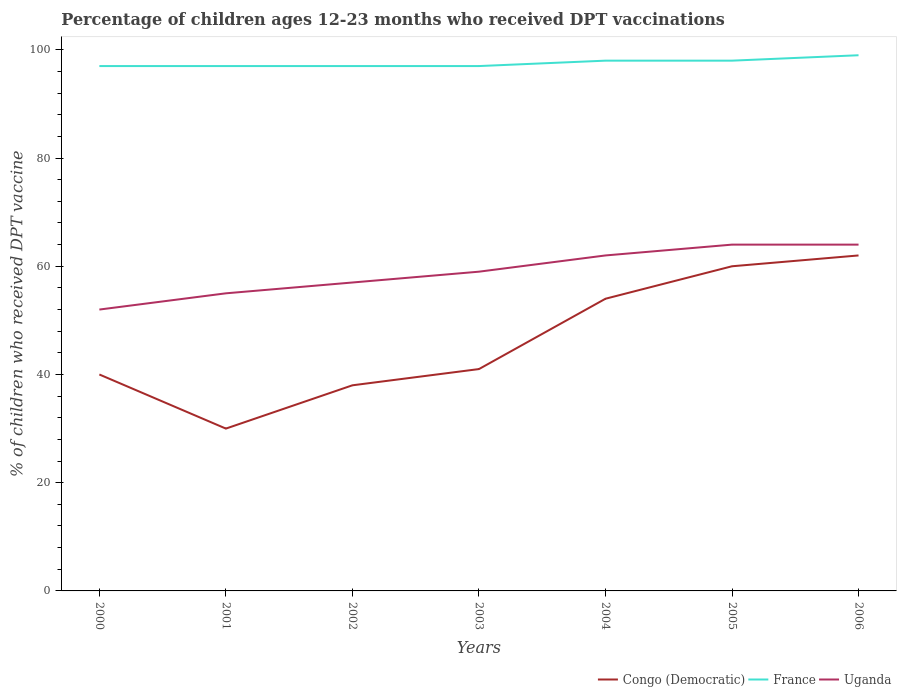How many different coloured lines are there?
Your answer should be compact. 3. Does the line corresponding to Uganda intersect with the line corresponding to France?
Your response must be concise. No. What is the difference between the highest and the second highest percentage of children who received DPT vaccination in France?
Provide a succinct answer. 2. What is the difference between the highest and the lowest percentage of children who received DPT vaccination in Uganda?
Provide a short and direct response. 3. Is the percentage of children who received DPT vaccination in France strictly greater than the percentage of children who received DPT vaccination in Uganda over the years?
Your response must be concise. No. How many lines are there?
Keep it short and to the point. 3. How many legend labels are there?
Make the answer very short. 3. How are the legend labels stacked?
Your response must be concise. Horizontal. What is the title of the graph?
Your answer should be compact. Percentage of children ages 12-23 months who received DPT vaccinations. What is the label or title of the Y-axis?
Offer a terse response. % of children who received DPT vaccine. What is the % of children who received DPT vaccine in Congo (Democratic) in 2000?
Your answer should be very brief. 40. What is the % of children who received DPT vaccine in France in 2000?
Your answer should be very brief. 97. What is the % of children who received DPT vaccine of France in 2001?
Provide a short and direct response. 97. What is the % of children who received DPT vaccine of Uganda in 2001?
Keep it short and to the point. 55. What is the % of children who received DPT vaccine in Congo (Democratic) in 2002?
Keep it short and to the point. 38. What is the % of children who received DPT vaccine of France in 2002?
Give a very brief answer. 97. What is the % of children who received DPT vaccine in Uganda in 2002?
Provide a short and direct response. 57. What is the % of children who received DPT vaccine in Congo (Democratic) in 2003?
Your response must be concise. 41. What is the % of children who received DPT vaccine of France in 2003?
Your response must be concise. 97. What is the % of children who received DPT vaccine in Uganda in 2004?
Provide a short and direct response. 62. What is the % of children who received DPT vaccine of Congo (Democratic) in 2006?
Ensure brevity in your answer.  62. What is the % of children who received DPT vaccine in France in 2006?
Ensure brevity in your answer.  99. What is the % of children who received DPT vaccine in Uganda in 2006?
Provide a short and direct response. 64. Across all years, what is the minimum % of children who received DPT vaccine in Congo (Democratic)?
Give a very brief answer. 30. Across all years, what is the minimum % of children who received DPT vaccine in France?
Provide a short and direct response. 97. What is the total % of children who received DPT vaccine of Congo (Democratic) in the graph?
Give a very brief answer. 325. What is the total % of children who received DPT vaccine of France in the graph?
Your response must be concise. 683. What is the total % of children who received DPT vaccine of Uganda in the graph?
Provide a short and direct response. 413. What is the difference between the % of children who received DPT vaccine in Congo (Democratic) in 2000 and that in 2002?
Give a very brief answer. 2. What is the difference between the % of children who received DPT vaccine of France in 2000 and that in 2002?
Give a very brief answer. 0. What is the difference between the % of children who received DPT vaccine in Uganda in 2000 and that in 2002?
Your answer should be very brief. -5. What is the difference between the % of children who received DPT vaccine of Congo (Democratic) in 2000 and that in 2003?
Ensure brevity in your answer.  -1. What is the difference between the % of children who received DPT vaccine in Uganda in 2000 and that in 2003?
Your answer should be very brief. -7. What is the difference between the % of children who received DPT vaccine of France in 2000 and that in 2004?
Your response must be concise. -1. What is the difference between the % of children who received DPT vaccine in Uganda in 2000 and that in 2004?
Make the answer very short. -10. What is the difference between the % of children who received DPT vaccine of Congo (Democratic) in 2000 and that in 2005?
Give a very brief answer. -20. What is the difference between the % of children who received DPT vaccine in France in 2000 and that in 2005?
Provide a short and direct response. -1. What is the difference between the % of children who received DPT vaccine in Uganda in 2000 and that in 2005?
Your answer should be compact. -12. What is the difference between the % of children who received DPT vaccine in France in 2000 and that in 2006?
Give a very brief answer. -2. What is the difference between the % of children who received DPT vaccine in Uganda in 2000 and that in 2006?
Give a very brief answer. -12. What is the difference between the % of children who received DPT vaccine of Congo (Democratic) in 2001 and that in 2002?
Make the answer very short. -8. What is the difference between the % of children who received DPT vaccine of France in 2001 and that in 2002?
Give a very brief answer. 0. What is the difference between the % of children who received DPT vaccine in Uganda in 2001 and that in 2002?
Make the answer very short. -2. What is the difference between the % of children who received DPT vaccine of Congo (Democratic) in 2001 and that in 2004?
Keep it short and to the point. -24. What is the difference between the % of children who received DPT vaccine of Uganda in 2001 and that in 2004?
Keep it short and to the point. -7. What is the difference between the % of children who received DPT vaccine of Congo (Democratic) in 2001 and that in 2005?
Give a very brief answer. -30. What is the difference between the % of children who received DPT vaccine of Uganda in 2001 and that in 2005?
Keep it short and to the point. -9. What is the difference between the % of children who received DPT vaccine in Congo (Democratic) in 2001 and that in 2006?
Provide a succinct answer. -32. What is the difference between the % of children who received DPT vaccine of Uganda in 2001 and that in 2006?
Ensure brevity in your answer.  -9. What is the difference between the % of children who received DPT vaccine in Congo (Democratic) in 2002 and that in 2003?
Provide a short and direct response. -3. What is the difference between the % of children who received DPT vaccine in Congo (Democratic) in 2002 and that in 2005?
Give a very brief answer. -22. What is the difference between the % of children who received DPT vaccine of France in 2002 and that in 2006?
Ensure brevity in your answer.  -2. What is the difference between the % of children who received DPT vaccine in Uganda in 2002 and that in 2006?
Keep it short and to the point. -7. What is the difference between the % of children who received DPT vaccine of Congo (Democratic) in 2003 and that in 2004?
Provide a succinct answer. -13. What is the difference between the % of children who received DPT vaccine of Uganda in 2003 and that in 2004?
Your answer should be compact. -3. What is the difference between the % of children who received DPT vaccine in Uganda in 2003 and that in 2005?
Your response must be concise. -5. What is the difference between the % of children who received DPT vaccine of Uganda in 2003 and that in 2006?
Ensure brevity in your answer.  -5. What is the difference between the % of children who received DPT vaccine in Congo (Democratic) in 2004 and that in 2005?
Give a very brief answer. -6. What is the difference between the % of children who received DPT vaccine of Congo (Democratic) in 2004 and that in 2006?
Your answer should be very brief. -8. What is the difference between the % of children who received DPT vaccine in France in 2004 and that in 2006?
Make the answer very short. -1. What is the difference between the % of children who received DPT vaccine of Uganda in 2004 and that in 2006?
Your response must be concise. -2. What is the difference between the % of children who received DPT vaccine in Congo (Democratic) in 2005 and that in 2006?
Give a very brief answer. -2. What is the difference between the % of children who received DPT vaccine of Uganda in 2005 and that in 2006?
Your answer should be very brief. 0. What is the difference between the % of children who received DPT vaccine in Congo (Democratic) in 2000 and the % of children who received DPT vaccine in France in 2001?
Give a very brief answer. -57. What is the difference between the % of children who received DPT vaccine of Congo (Democratic) in 2000 and the % of children who received DPT vaccine of Uganda in 2001?
Give a very brief answer. -15. What is the difference between the % of children who received DPT vaccine of France in 2000 and the % of children who received DPT vaccine of Uganda in 2001?
Provide a succinct answer. 42. What is the difference between the % of children who received DPT vaccine of Congo (Democratic) in 2000 and the % of children who received DPT vaccine of France in 2002?
Make the answer very short. -57. What is the difference between the % of children who received DPT vaccine in France in 2000 and the % of children who received DPT vaccine in Uganda in 2002?
Your response must be concise. 40. What is the difference between the % of children who received DPT vaccine of Congo (Democratic) in 2000 and the % of children who received DPT vaccine of France in 2003?
Offer a terse response. -57. What is the difference between the % of children who received DPT vaccine of Congo (Democratic) in 2000 and the % of children who received DPT vaccine of Uganda in 2003?
Provide a short and direct response. -19. What is the difference between the % of children who received DPT vaccine of France in 2000 and the % of children who received DPT vaccine of Uganda in 2003?
Provide a succinct answer. 38. What is the difference between the % of children who received DPT vaccine in Congo (Democratic) in 2000 and the % of children who received DPT vaccine in France in 2004?
Make the answer very short. -58. What is the difference between the % of children who received DPT vaccine of Congo (Democratic) in 2000 and the % of children who received DPT vaccine of France in 2005?
Keep it short and to the point. -58. What is the difference between the % of children who received DPT vaccine in France in 2000 and the % of children who received DPT vaccine in Uganda in 2005?
Your answer should be compact. 33. What is the difference between the % of children who received DPT vaccine in Congo (Democratic) in 2000 and the % of children who received DPT vaccine in France in 2006?
Your answer should be compact. -59. What is the difference between the % of children who received DPT vaccine in Congo (Democratic) in 2001 and the % of children who received DPT vaccine in France in 2002?
Your answer should be compact. -67. What is the difference between the % of children who received DPT vaccine of Congo (Democratic) in 2001 and the % of children who received DPT vaccine of France in 2003?
Your answer should be very brief. -67. What is the difference between the % of children who received DPT vaccine of Congo (Democratic) in 2001 and the % of children who received DPT vaccine of France in 2004?
Give a very brief answer. -68. What is the difference between the % of children who received DPT vaccine of Congo (Democratic) in 2001 and the % of children who received DPT vaccine of Uganda in 2004?
Provide a short and direct response. -32. What is the difference between the % of children who received DPT vaccine in France in 2001 and the % of children who received DPT vaccine in Uganda in 2004?
Your answer should be compact. 35. What is the difference between the % of children who received DPT vaccine of Congo (Democratic) in 2001 and the % of children who received DPT vaccine of France in 2005?
Give a very brief answer. -68. What is the difference between the % of children who received DPT vaccine in Congo (Democratic) in 2001 and the % of children who received DPT vaccine in Uganda in 2005?
Offer a terse response. -34. What is the difference between the % of children who received DPT vaccine of Congo (Democratic) in 2001 and the % of children who received DPT vaccine of France in 2006?
Provide a short and direct response. -69. What is the difference between the % of children who received DPT vaccine of Congo (Democratic) in 2001 and the % of children who received DPT vaccine of Uganda in 2006?
Provide a short and direct response. -34. What is the difference between the % of children who received DPT vaccine in France in 2001 and the % of children who received DPT vaccine in Uganda in 2006?
Your response must be concise. 33. What is the difference between the % of children who received DPT vaccine of Congo (Democratic) in 2002 and the % of children who received DPT vaccine of France in 2003?
Ensure brevity in your answer.  -59. What is the difference between the % of children who received DPT vaccine in Congo (Democratic) in 2002 and the % of children who received DPT vaccine in France in 2004?
Offer a terse response. -60. What is the difference between the % of children who received DPT vaccine in Congo (Democratic) in 2002 and the % of children who received DPT vaccine in Uganda in 2004?
Provide a short and direct response. -24. What is the difference between the % of children who received DPT vaccine in France in 2002 and the % of children who received DPT vaccine in Uganda in 2004?
Your answer should be very brief. 35. What is the difference between the % of children who received DPT vaccine of Congo (Democratic) in 2002 and the % of children who received DPT vaccine of France in 2005?
Provide a short and direct response. -60. What is the difference between the % of children who received DPT vaccine of France in 2002 and the % of children who received DPT vaccine of Uganda in 2005?
Provide a short and direct response. 33. What is the difference between the % of children who received DPT vaccine in Congo (Democratic) in 2002 and the % of children who received DPT vaccine in France in 2006?
Offer a terse response. -61. What is the difference between the % of children who received DPT vaccine of Congo (Democratic) in 2003 and the % of children who received DPT vaccine of France in 2004?
Your answer should be very brief. -57. What is the difference between the % of children who received DPT vaccine in Congo (Democratic) in 2003 and the % of children who received DPT vaccine in France in 2005?
Provide a succinct answer. -57. What is the difference between the % of children who received DPT vaccine of Congo (Democratic) in 2003 and the % of children who received DPT vaccine of Uganda in 2005?
Offer a terse response. -23. What is the difference between the % of children who received DPT vaccine in Congo (Democratic) in 2003 and the % of children who received DPT vaccine in France in 2006?
Provide a short and direct response. -58. What is the difference between the % of children who received DPT vaccine in Congo (Democratic) in 2003 and the % of children who received DPT vaccine in Uganda in 2006?
Provide a short and direct response. -23. What is the difference between the % of children who received DPT vaccine in France in 2003 and the % of children who received DPT vaccine in Uganda in 2006?
Your answer should be very brief. 33. What is the difference between the % of children who received DPT vaccine of Congo (Democratic) in 2004 and the % of children who received DPT vaccine of France in 2005?
Give a very brief answer. -44. What is the difference between the % of children who received DPT vaccine in Congo (Democratic) in 2004 and the % of children who received DPT vaccine in France in 2006?
Ensure brevity in your answer.  -45. What is the difference between the % of children who received DPT vaccine of France in 2004 and the % of children who received DPT vaccine of Uganda in 2006?
Your answer should be very brief. 34. What is the difference between the % of children who received DPT vaccine of Congo (Democratic) in 2005 and the % of children who received DPT vaccine of France in 2006?
Offer a very short reply. -39. What is the difference between the % of children who received DPT vaccine in Congo (Democratic) in 2005 and the % of children who received DPT vaccine in Uganda in 2006?
Offer a terse response. -4. What is the difference between the % of children who received DPT vaccine of France in 2005 and the % of children who received DPT vaccine of Uganda in 2006?
Provide a short and direct response. 34. What is the average % of children who received DPT vaccine of Congo (Democratic) per year?
Ensure brevity in your answer.  46.43. What is the average % of children who received DPT vaccine of France per year?
Offer a very short reply. 97.57. In the year 2000, what is the difference between the % of children who received DPT vaccine of Congo (Democratic) and % of children who received DPT vaccine of France?
Keep it short and to the point. -57. In the year 2000, what is the difference between the % of children who received DPT vaccine of Congo (Democratic) and % of children who received DPT vaccine of Uganda?
Provide a short and direct response. -12. In the year 2001, what is the difference between the % of children who received DPT vaccine of Congo (Democratic) and % of children who received DPT vaccine of France?
Your answer should be compact. -67. In the year 2001, what is the difference between the % of children who received DPT vaccine of Congo (Democratic) and % of children who received DPT vaccine of Uganda?
Ensure brevity in your answer.  -25. In the year 2002, what is the difference between the % of children who received DPT vaccine of Congo (Democratic) and % of children who received DPT vaccine of France?
Your answer should be very brief. -59. In the year 2003, what is the difference between the % of children who received DPT vaccine of Congo (Democratic) and % of children who received DPT vaccine of France?
Ensure brevity in your answer.  -56. In the year 2003, what is the difference between the % of children who received DPT vaccine in Congo (Democratic) and % of children who received DPT vaccine in Uganda?
Offer a very short reply. -18. In the year 2004, what is the difference between the % of children who received DPT vaccine in Congo (Democratic) and % of children who received DPT vaccine in France?
Make the answer very short. -44. In the year 2004, what is the difference between the % of children who received DPT vaccine of France and % of children who received DPT vaccine of Uganda?
Offer a terse response. 36. In the year 2005, what is the difference between the % of children who received DPT vaccine in Congo (Democratic) and % of children who received DPT vaccine in France?
Offer a terse response. -38. In the year 2005, what is the difference between the % of children who received DPT vaccine in France and % of children who received DPT vaccine in Uganda?
Keep it short and to the point. 34. In the year 2006, what is the difference between the % of children who received DPT vaccine of Congo (Democratic) and % of children who received DPT vaccine of France?
Your answer should be very brief. -37. What is the ratio of the % of children who received DPT vaccine of Congo (Democratic) in 2000 to that in 2001?
Provide a succinct answer. 1.33. What is the ratio of the % of children who received DPT vaccine in France in 2000 to that in 2001?
Keep it short and to the point. 1. What is the ratio of the % of children who received DPT vaccine in Uganda in 2000 to that in 2001?
Your response must be concise. 0.95. What is the ratio of the % of children who received DPT vaccine in Congo (Democratic) in 2000 to that in 2002?
Give a very brief answer. 1.05. What is the ratio of the % of children who received DPT vaccine in Uganda in 2000 to that in 2002?
Offer a very short reply. 0.91. What is the ratio of the % of children who received DPT vaccine of Congo (Democratic) in 2000 to that in 2003?
Keep it short and to the point. 0.98. What is the ratio of the % of children who received DPT vaccine in France in 2000 to that in 2003?
Keep it short and to the point. 1. What is the ratio of the % of children who received DPT vaccine of Uganda in 2000 to that in 2003?
Give a very brief answer. 0.88. What is the ratio of the % of children who received DPT vaccine of Congo (Democratic) in 2000 to that in 2004?
Give a very brief answer. 0.74. What is the ratio of the % of children who received DPT vaccine in Uganda in 2000 to that in 2004?
Offer a very short reply. 0.84. What is the ratio of the % of children who received DPT vaccine of Congo (Democratic) in 2000 to that in 2005?
Ensure brevity in your answer.  0.67. What is the ratio of the % of children who received DPT vaccine of France in 2000 to that in 2005?
Keep it short and to the point. 0.99. What is the ratio of the % of children who received DPT vaccine of Uganda in 2000 to that in 2005?
Offer a very short reply. 0.81. What is the ratio of the % of children who received DPT vaccine of Congo (Democratic) in 2000 to that in 2006?
Provide a short and direct response. 0.65. What is the ratio of the % of children who received DPT vaccine in France in 2000 to that in 2006?
Your response must be concise. 0.98. What is the ratio of the % of children who received DPT vaccine of Uganda in 2000 to that in 2006?
Provide a short and direct response. 0.81. What is the ratio of the % of children who received DPT vaccine of Congo (Democratic) in 2001 to that in 2002?
Make the answer very short. 0.79. What is the ratio of the % of children who received DPT vaccine of Uganda in 2001 to that in 2002?
Keep it short and to the point. 0.96. What is the ratio of the % of children who received DPT vaccine of Congo (Democratic) in 2001 to that in 2003?
Make the answer very short. 0.73. What is the ratio of the % of children who received DPT vaccine in Uganda in 2001 to that in 2003?
Offer a terse response. 0.93. What is the ratio of the % of children who received DPT vaccine of Congo (Democratic) in 2001 to that in 2004?
Offer a very short reply. 0.56. What is the ratio of the % of children who received DPT vaccine of Uganda in 2001 to that in 2004?
Your response must be concise. 0.89. What is the ratio of the % of children who received DPT vaccine in France in 2001 to that in 2005?
Your response must be concise. 0.99. What is the ratio of the % of children who received DPT vaccine of Uganda in 2001 to that in 2005?
Ensure brevity in your answer.  0.86. What is the ratio of the % of children who received DPT vaccine in Congo (Democratic) in 2001 to that in 2006?
Your answer should be compact. 0.48. What is the ratio of the % of children who received DPT vaccine of France in 2001 to that in 2006?
Your response must be concise. 0.98. What is the ratio of the % of children who received DPT vaccine in Uganda in 2001 to that in 2006?
Provide a short and direct response. 0.86. What is the ratio of the % of children who received DPT vaccine in Congo (Democratic) in 2002 to that in 2003?
Give a very brief answer. 0.93. What is the ratio of the % of children who received DPT vaccine of France in 2002 to that in 2003?
Ensure brevity in your answer.  1. What is the ratio of the % of children who received DPT vaccine in Uganda in 2002 to that in 2003?
Your answer should be compact. 0.97. What is the ratio of the % of children who received DPT vaccine of Congo (Democratic) in 2002 to that in 2004?
Offer a terse response. 0.7. What is the ratio of the % of children who received DPT vaccine of Uganda in 2002 to that in 2004?
Your answer should be compact. 0.92. What is the ratio of the % of children who received DPT vaccine in Congo (Democratic) in 2002 to that in 2005?
Your answer should be very brief. 0.63. What is the ratio of the % of children who received DPT vaccine of France in 2002 to that in 2005?
Give a very brief answer. 0.99. What is the ratio of the % of children who received DPT vaccine in Uganda in 2002 to that in 2005?
Make the answer very short. 0.89. What is the ratio of the % of children who received DPT vaccine in Congo (Democratic) in 2002 to that in 2006?
Ensure brevity in your answer.  0.61. What is the ratio of the % of children who received DPT vaccine in France in 2002 to that in 2006?
Keep it short and to the point. 0.98. What is the ratio of the % of children who received DPT vaccine of Uganda in 2002 to that in 2006?
Your answer should be compact. 0.89. What is the ratio of the % of children who received DPT vaccine in Congo (Democratic) in 2003 to that in 2004?
Give a very brief answer. 0.76. What is the ratio of the % of children who received DPT vaccine of Uganda in 2003 to that in 2004?
Your response must be concise. 0.95. What is the ratio of the % of children who received DPT vaccine in Congo (Democratic) in 2003 to that in 2005?
Give a very brief answer. 0.68. What is the ratio of the % of children who received DPT vaccine in France in 2003 to that in 2005?
Provide a short and direct response. 0.99. What is the ratio of the % of children who received DPT vaccine in Uganda in 2003 to that in 2005?
Make the answer very short. 0.92. What is the ratio of the % of children who received DPT vaccine in Congo (Democratic) in 2003 to that in 2006?
Ensure brevity in your answer.  0.66. What is the ratio of the % of children who received DPT vaccine of France in 2003 to that in 2006?
Your answer should be very brief. 0.98. What is the ratio of the % of children who received DPT vaccine of Uganda in 2003 to that in 2006?
Provide a succinct answer. 0.92. What is the ratio of the % of children who received DPT vaccine of France in 2004 to that in 2005?
Provide a succinct answer. 1. What is the ratio of the % of children who received DPT vaccine of Uganda in 2004 to that in 2005?
Your answer should be compact. 0.97. What is the ratio of the % of children who received DPT vaccine in Congo (Democratic) in 2004 to that in 2006?
Make the answer very short. 0.87. What is the ratio of the % of children who received DPT vaccine in Uganda in 2004 to that in 2006?
Make the answer very short. 0.97. What is the ratio of the % of children who received DPT vaccine in France in 2005 to that in 2006?
Your answer should be compact. 0.99. What is the difference between the highest and the second highest % of children who received DPT vaccine in Congo (Democratic)?
Offer a very short reply. 2. What is the difference between the highest and the second highest % of children who received DPT vaccine of France?
Provide a succinct answer. 1. What is the difference between the highest and the second highest % of children who received DPT vaccine in Uganda?
Your response must be concise. 0. What is the difference between the highest and the lowest % of children who received DPT vaccine in Congo (Democratic)?
Keep it short and to the point. 32. What is the difference between the highest and the lowest % of children who received DPT vaccine of France?
Offer a terse response. 2. 